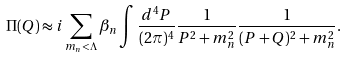Convert formula to latex. <formula><loc_0><loc_0><loc_500><loc_500>\Pi ( Q ) \approx i \sum _ { m _ { n } < \Lambda } \beta _ { n } \int \frac { d ^ { 4 } P } { ( 2 \pi ) ^ { 4 } } \frac { 1 } { P ^ { 2 } + m _ { n } ^ { 2 } } \frac { 1 } { ( P + Q ) ^ { 2 } + m _ { n } ^ { 2 } } .</formula> 